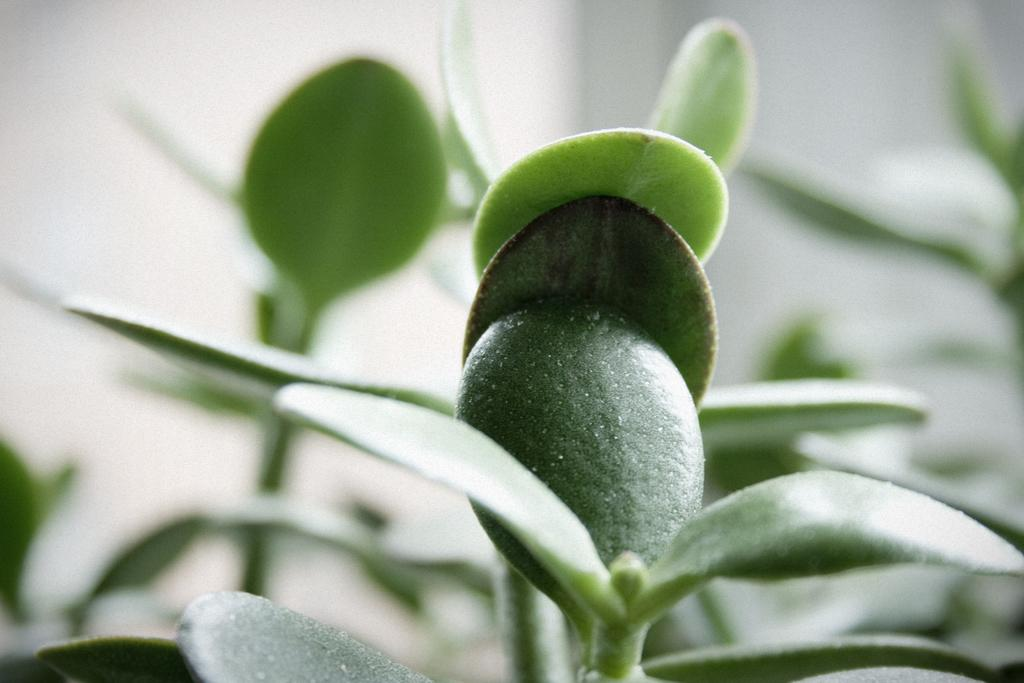What type of vegetation is present in the image? There are green leaves in the image. Can you describe the background of the image? The background of the image is blurred. What type of lace can be seen on the leaves in the image? There is no lace present on the leaves in the image; they are simply green leaves. 